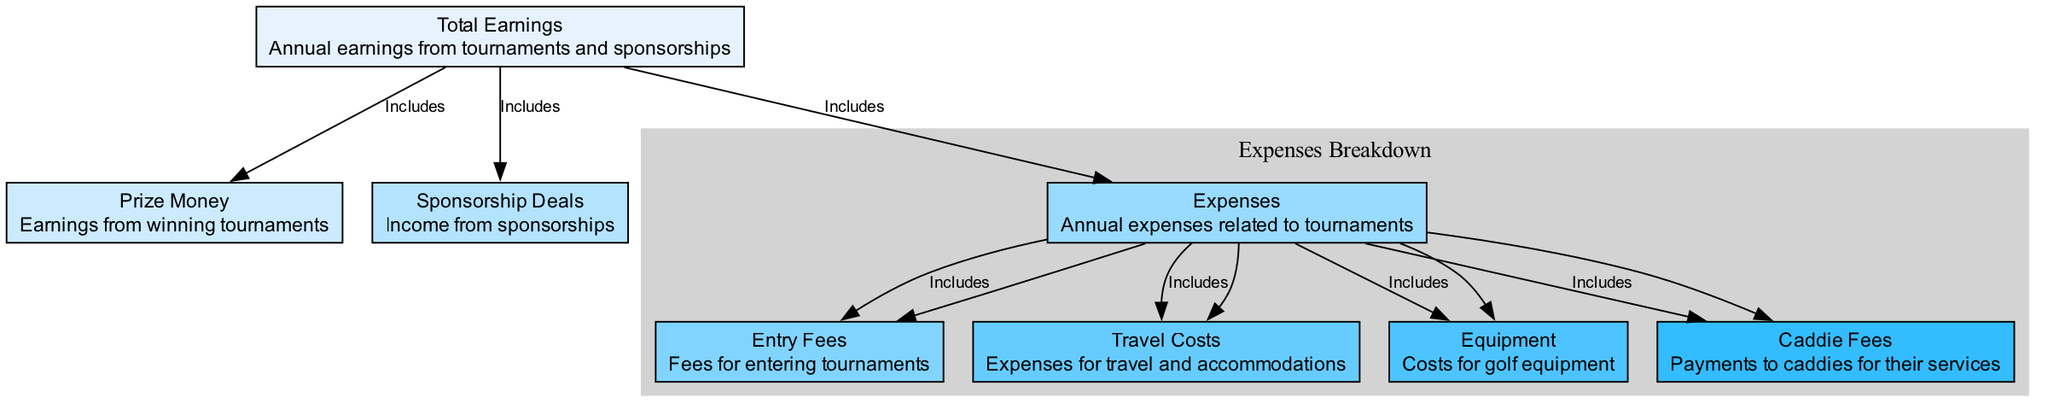What is the main category of Total Earnings? Total Earnings include both Prize Money and Sponsorship Deals, indicating that these are the primary sources of income for a professional golfer.
Answer: Annual earnings from tournaments and sponsorships How many expenses are included under Expenses? The Expenses node includes four subcategories: Entry Fees, Travel Costs, Equipment, and Caddie Fees, totaling four expense types that a golfer incurs during the year.
Answer: 4 What type of income is Sponsorship Deals? Sponsorship Deals is classified as a source of income separate from Prize Money, contributing to the overall Total Earnings of the golfer.
Answer: Income Which expense highest category do Entry Fees represent? Entry Fees fall under the broader category of Expenses, which encompasses various costs incurred for golfing competitions but is a specific expense type within that grouping.
Answer: Expenses From which node does Travel Costs derive? Travel Costs, representing expenses related to travel and accommodations, is derived from the Expenses node, linking it to the overall costs incurred by the golfer during the year.
Answer: Expenses What do all expenses represent in the context of the diagram? All expenses represent the financial outflow that a golfer incurs in their professional journey, grouped under the Expenses node of the diagram.
Answer: Annual expenses related to tournaments Which nodes are included in Total Earnings? Total Earnings include both Prize Money and Sponsorship Deals, indicating that these sources of income collectively contribute to annual financial success for golfers.
Answer: Prize Money, Sponsorship Deals How many edges connect the node of Expenses to its subcategories? The Expenses node is connected to four specific expense types through edges, showing a comprehensive breakdown of its financial components.
Answer: 4 What is the interrelation between Prize Money and Total Earnings? Prize Money directly contributes to Total Earnings, indicating that the golfer's success in tournaments translates into financial income within the year.
Answer: Includes 